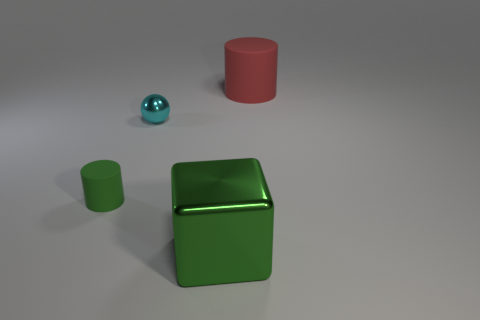The green rubber thing that is the same shape as the big red thing is what size?
Keep it short and to the point. Small. How many gray cubes have the same material as the big cylinder?
Your answer should be compact. 0. Do the big shiny thing and the rubber thing in front of the big red cylinder have the same color?
Provide a short and direct response. Yes. Is the number of red cylinders greater than the number of brown objects?
Provide a short and direct response. Yes. The small shiny sphere has what color?
Give a very brief answer. Cyan. There is a matte object to the right of the cyan metallic sphere; does it have the same color as the ball?
Provide a succinct answer. No. There is a cylinder that is the same color as the metallic cube; what is it made of?
Your response must be concise. Rubber. How many shiny balls have the same color as the big rubber cylinder?
Give a very brief answer. 0. There is a large object that is left of the large red rubber thing; is it the same shape as the tiny cyan metal thing?
Keep it short and to the point. No. Is the number of large things behind the large green object less than the number of red matte cylinders on the left side of the tiny green cylinder?
Your answer should be very brief. No. 